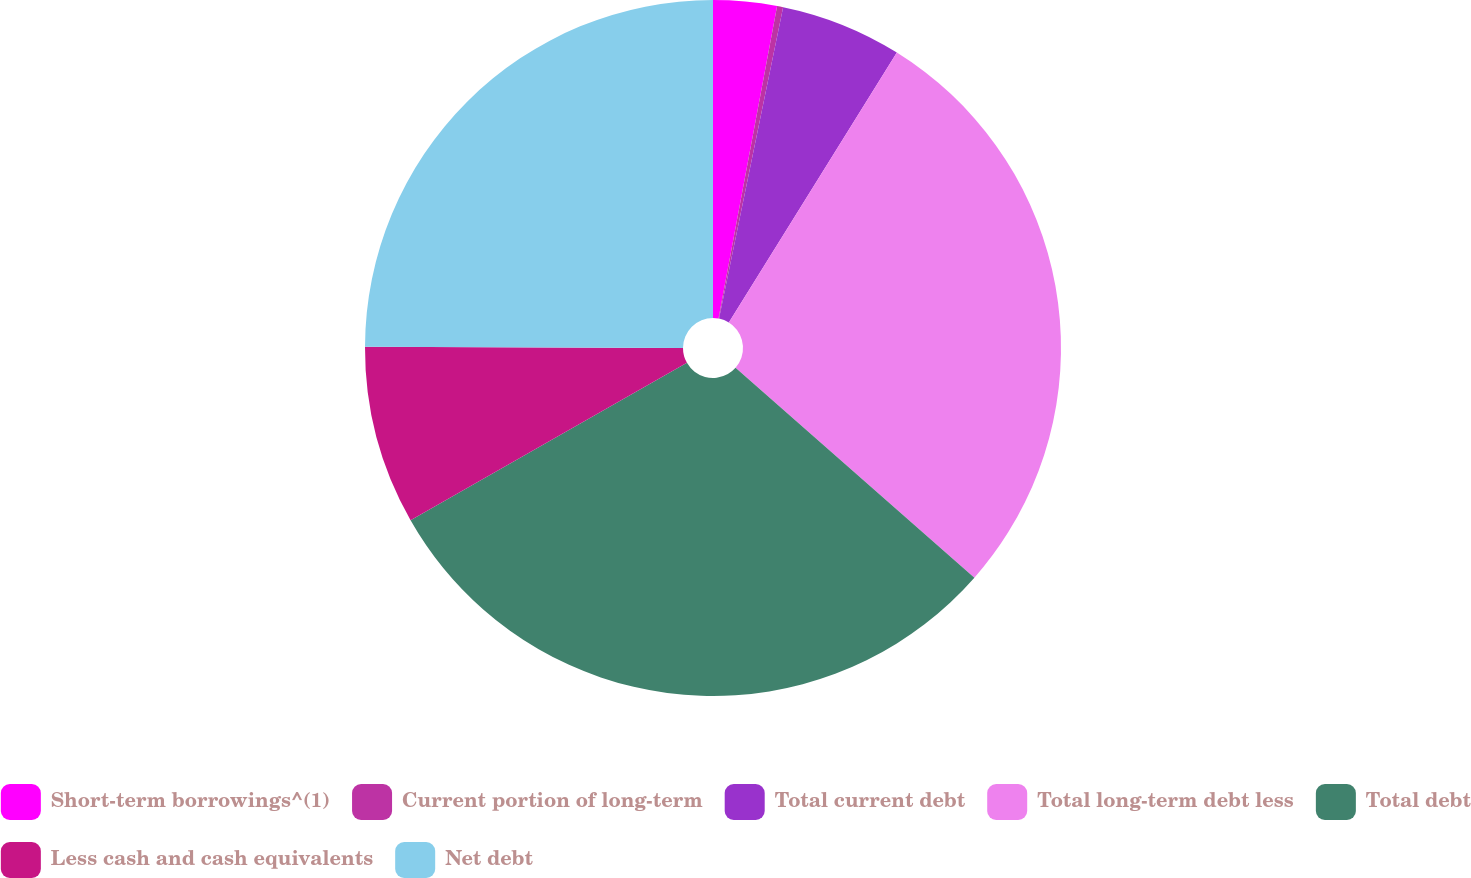Convert chart. <chart><loc_0><loc_0><loc_500><loc_500><pie_chart><fcel>Short-term borrowings^(1)<fcel>Current portion of long-term<fcel>Total current debt<fcel>Total long-term debt less<fcel>Total debt<fcel>Less cash and cash equivalents<fcel>Net debt<nl><fcel>2.95%<fcel>0.28%<fcel>5.63%<fcel>27.62%<fcel>30.29%<fcel>8.3%<fcel>24.94%<nl></chart> 